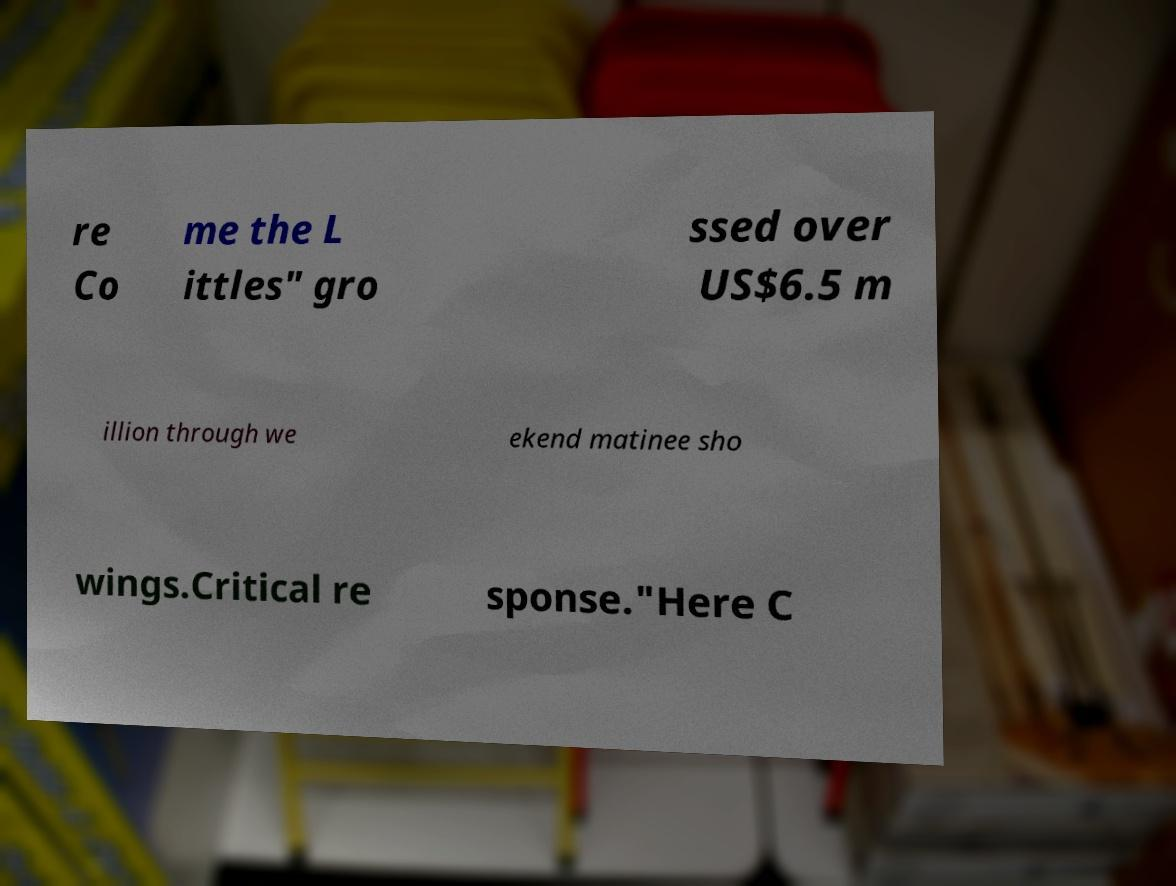What messages or text are displayed in this image? I need them in a readable, typed format. re Co me the L ittles" gro ssed over US$6.5 m illion through we ekend matinee sho wings.Critical re sponse."Here C 